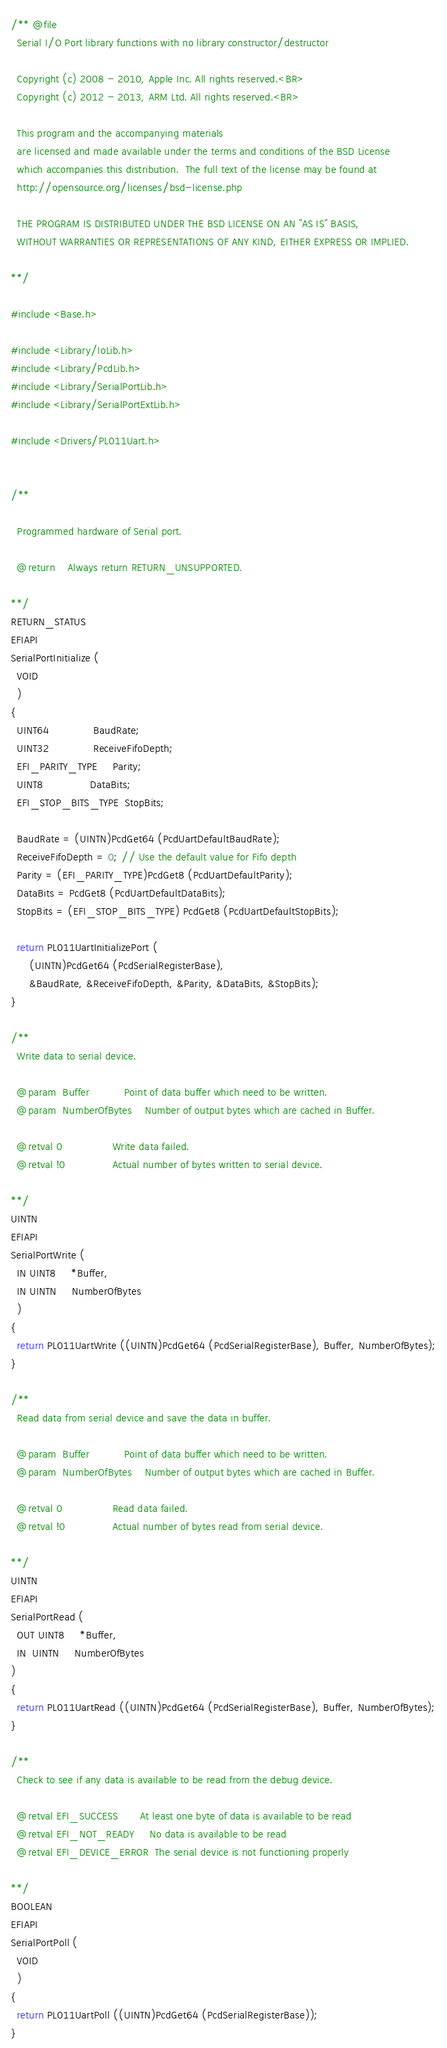Convert code to text. <code><loc_0><loc_0><loc_500><loc_500><_C_>/** @file
  Serial I/O Port library functions with no library constructor/destructor

  Copyright (c) 2008 - 2010, Apple Inc. All rights reserved.<BR>
  Copyright (c) 2012 - 2013, ARM Ltd. All rights reserved.<BR>

  This program and the accompanying materials
  are licensed and made available under the terms and conditions of the BSD License
  which accompanies this distribution.  The full text of the license may be found at
  http://opensource.org/licenses/bsd-license.php

  THE PROGRAM IS DISTRIBUTED UNDER THE BSD LICENSE ON AN "AS IS" BASIS,
  WITHOUT WARRANTIES OR REPRESENTATIONS OF ANY KIND, EITHER EXPRESS OR IMPLIED.

**/

#include <Base.h>

#include <Library/IoLib.h>
#include <Library/PcdLib.h>
#include <Library/SerialPortLib.h>
#include <Library/SerialPortExtLib.h>

#include <Drivers/PL011Uart.h>


/**

  Programmed hardware of Serial port.

  @return    Always return RETURN_UNSUPPORTED.

**/
RETURN_STATUS
EFIAPI
SerialPortInitialize (
  VOID
  )
{
  UINT64              BaudRate;
  UINT32              ReceiveFifoDepth;
  EFI_PARITY_TYPE     Parity;
  UINT8               DataBits;
  EFI_STOP_BITS_TYPE  StopBits;

  BaudRate = (UINTN)PcdGet64 (PcdUartDefaultBaudRate);
  ReceiveFifoDepth = 0; // Use the default value for Fifo depth
  Parity = (EFI_PARITY_TYPE)PcdGet8 (PcdUartDefaultParity);
  DataBits = PcdGet8 (PcdUartDefaultDataBits);
  StopBits = (EFI_STOP_BITS_TYPE) PcdGet8 (PcdUartDefaultStopBits);

  return PL011UartInitializePort (
      (UINTN)PcdGet64 (PcdSerialRegisterBase),
      &BaudRate, &ReceiveFifoDepth, &Parity, &DataBits, &StopBits);
}

/**
  Write data to serial device.

  @param  Buffer           Point of data buffer which need to be written.
  @param  NumberOfBytes    Number of output bytes which are cached in Buffer.

  @retval 0                Write data failed.
  @retval !0               Actual number of bytes written to serial device.

**/
UINTN
EFIAPI
SerialPortWrite (
  IN UINT8     *Buffer,
  IN UINTN     NumberOfBytes
  )
{
  return PL011UartWrite ((UINTN)PcdGet64 (PcdSerialRegisterBase), Buffer, NumberOfBytes);
}

/**
  Read data from serial device and save the data in buffer.

  @param  Buffer           Point of data buffer which need to be written.
  @param  NumberOfBytes    Number of output bytes which are cached in Buffer.

  @retval 0                Read data failed.
  @retval !0               Actual number of bytes read from serial device.

**/
UINTN
EFIAPI
SerialPortRead (
  OUT UINT8     *Buffer,
  IN  UINTN     NumberOfBytes
)
{
  return PL011UartRead ((UINTN)PcdGet64 (PcdSerialRegisterBase), Buffer, NumberOfBytes);
}

/**
  Check to see if any data is available to be read from the debug device.

  @retval EFI_SUCCESS       At least one byte of data is available to be read
  @retval EFI_NOT_READY     No data is available to be read
  @retval EFI_DEVICE_ERROR  The serial device is not functioning properly

**/
BOOLEAN
EFIAPI
SerialPortPoll (
  VOID
  )
{
  return PL011UartPoll ((UINTN)PcdGet64 (PcdSerialRegisterBase));
}

</code> 